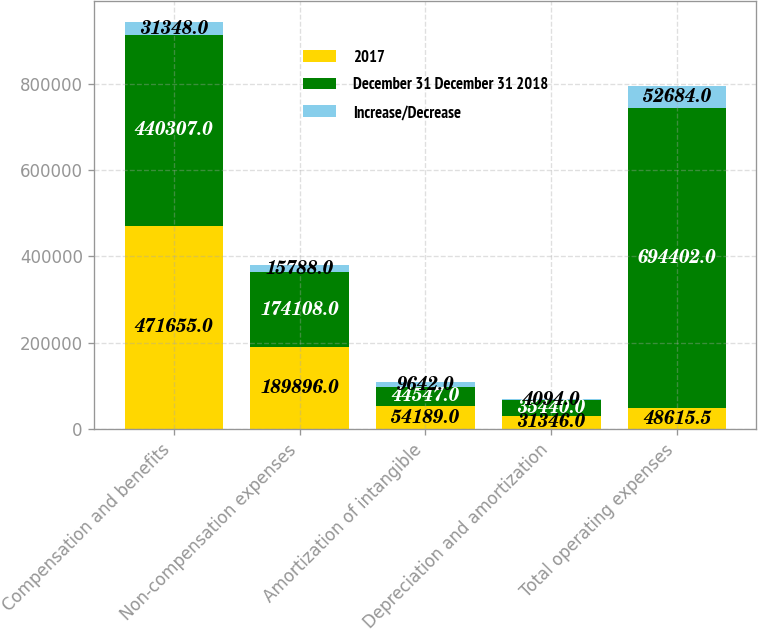<chart> <loc_0><loc_0><loc_500><loc_500><stacked_bar_chart><ecel><fcel>Compensation and benefits<fcel>Non-compensation expenses<fcel>Amortization of intangible<fcel>Depreciation and amortization<fcel>Total operating expenses<nl><fcel>2017<fcel>471655<fcel>189896<fcel>54189<fcel>31346<fcel>48615.5<nl><fcel>December 31 December 31 2018<fcel>440307<fcel>174108<fcel>44547<fcel>35440<fcel>694402<nl><fcel>Increase/Decrease<fcel>31348<fcel>15788<fcel>9642<fcel>4094<fcel>52684<nl></chart> 